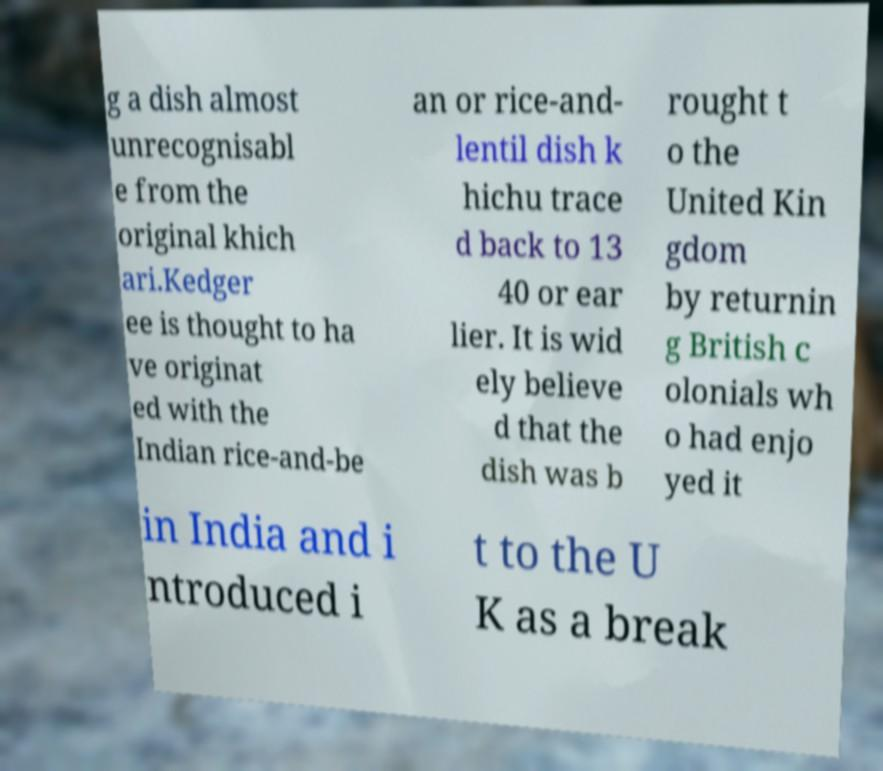I need the written content from this picture converted into text. Can you do that? g a dish almost unrecognisabl e from the original khich ari.Kedger ee is thought to ha ve originat ed with the Indian rice-and-be an or rice-and- lentil dish k hichu trace d back to 13 40 or ear lier. It is wid ely believe d that the dish was b rought t o the United Kin gdom by returnin g British c olonials wh o had enjo yed it in India and i ntroduced i t to the U K as a break 